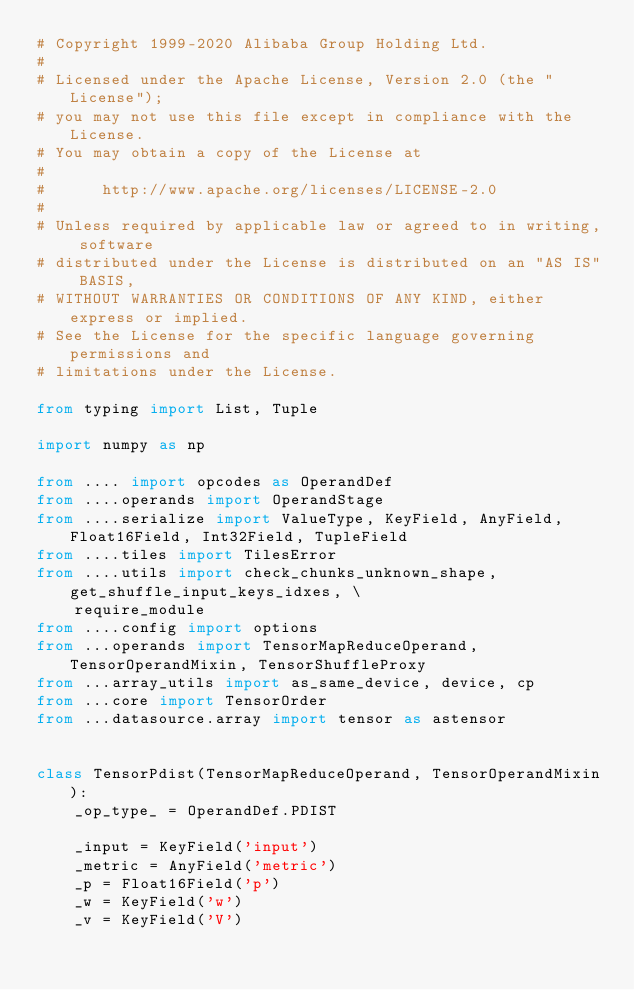Convert code to text. <code><loc_0><loc_0><loc_500><loc_500><_Python_># Copyright 1999-2020 Alibaba Group Holding Ltd.
#
# Licensed under the Apache License, Version 2.0 (the "License");
# you may not use this file except in compliance with the License.
# You may obtain a copy of the License at
#
#      http://www.apache.org/licenses/LICENSE-2.0
#
# Unless required by applicable law or agreed to in writing, software
# distributed under the License is distributed on an "AS IS" BASIS,
# WITHOUT WARRANTIES OR CONDITIONS OF ANY KIND, either express or implied.
# See the License for the specific language governing permissions and
# limitations under the License.

from typing import List, Tuple

import numpy as np

from .... import opcodes as OperandDef
from ....operands import OperandStage
from ....serialize import ValueType, KeyField, AnyField, Float16Field, Int32Field, TupleField
from ....tiles import TilesError
from ....utils import check_chunks_unknown_shape, get_shuffle_input_keys_idxes, \
    require_module
from ....config import options
from ...operands import TensorMapReduceOperand, TensorOperandMixin, TensorShuffleProxy
from ...array_utils import as_same_device, device, cp
from ...core import TensorOrder
from ...datasource.array import tensor as astensor


class TensorPdist(TensorMapReduceOperand, TensorOperandMixin):
    _op_type_ = OperandDef.PDIST

    _input = KeyField('input')
    _metric = AnyField('metric')
    _p = Float16Field('p')
    _w = KeyField('w')
    _v = KeyField('V')</code> 